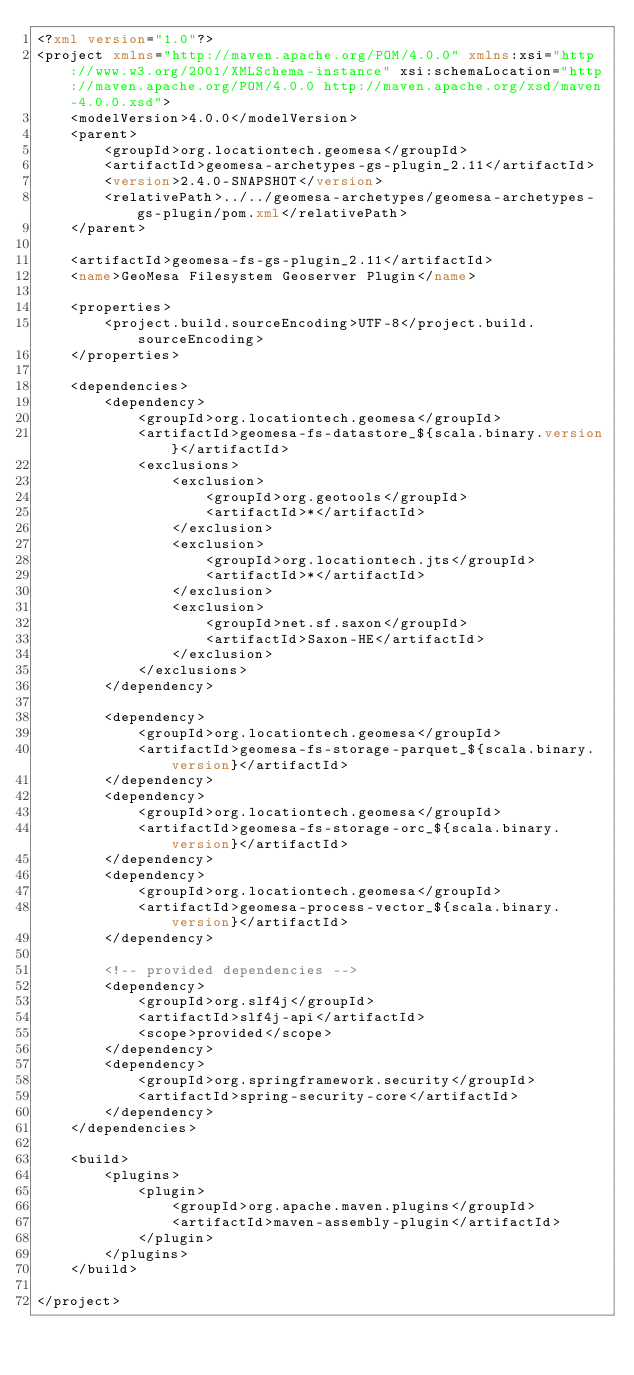<code> <loc_0><loc_0><loc_500><loc_500><_XML_><?xml version="1.0"?>
<project xmlns="http://maven.apache.org/POM/4.0.0" xmlns:xsi="http://www.w3.org/2001/XMLSchema-instance" xsi:schemaLocation="http://maven.apache.org/POM/4.0.0 http://maven.apache.org/xsd/maven-4.0.0.xsd">
    <modelVersion>4.0.0</modelVersion>
    <parent>
        <groupId>org.locationtech.geomesa</groupId>
        <artifactId>geomesa-archetypes-gs-plugin_2.11</artifactId>
        <version>2.4.0-SNAPSHOT</version>
        <relativePath>../../geomesa-archetypes/geomesa-archetypes-gs-plugin/pom.xml</relativePath>
    </parent>

    <artifactId>geomesa-fs-gs-plugin_2.11</artifactId>
    <name>GeoMesa Filesystem Geoserver Plugin</name>

    <properties>
        <project.build.sourceEncoding>UTF-8</project.build.sourceEncoding>
    </properties>

    <dependencies>
        <dependency>
            <groupId>org.locationtech.geomesa</groupId>
            <artifactId>geomesa-fs-datastore_${scala.binary.version}</artifactId>
            <exclusions>
                <exclusion>
                    <groupId>org.geotools</groupId>
                    <artifactId>*</artifactId>
                </exclusion>
                <exclusion>
                    <groupId>org.locationtech.jts</groupId>
                    <artifactId>*</artifactId>
                </exclusion>
                <exclusion>
                    <groupId>net.sf.saxon</groupId>
                    <artifactId>Saxon-HE</artifactId>
                </exclusion>
            </exclusions>
        </dependency>

        <dependency>
            <groupId>org.locationtech.geomesa</groupId>
            <artifactId>geomesa-fs-storage-parquet_${scala.binary.version}</artifactId>
        </dependency>
        <dependency>
            <groupId>org.locationtech.geomesa</groupId>
            <artifactId>geomesa-fs-storage-orc_${scala.binary.version}</artifactId>
        </dependency>
        <dependency>
            <groupId>org.locationtech.geomesa</groupId>
            <artifactId>geomesa-process-vector_${scala.binary.version}</artifactId>
        </dependency>

        <!-- provided dependencies -->
        <dependency>
            <groupId>org.slf4j</groupId>
            <artifactId>slf4j-api</artifactId>
            <scope>provided</scope>
        </dependency>
        <dependency>
            <groupId>org.springframework.security</groupId>
            <artifactId>spring-security-core</artifactId>
        </dependency>
    </dependencies>

    <build>
        <plugins>
            <plugin>
                <groupId>org.apache.maven.plugins</groupId>
                <artifactId>maven-assembly-plugin</artifactId>
            </plugin>
        </plugins>
    </build>

</project>
</code> 